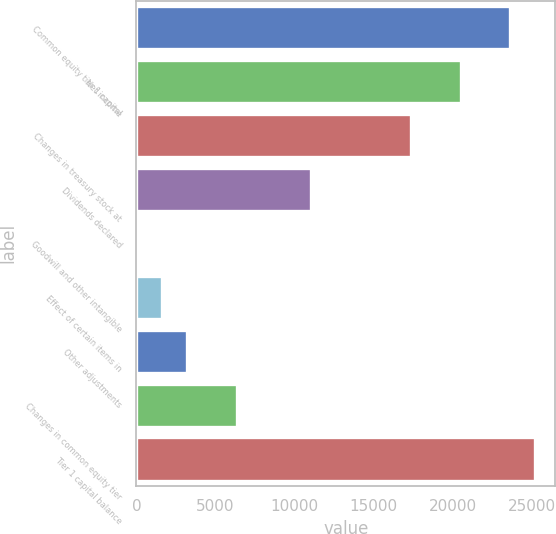Convert chart. <chart><loc_0><loc_0><loc_500><loc_500><bar_chart><fcel>Common equity tier 1 capital<fcel>Net income<fcel>Changes in treasury stock at<fcel>Dividends declared<fcel>Goodwill and other intangible<fcel>Effect of certain items in<fcel>Other adjustments<fcel>Changes in common equity tier<fcel>Tier 1 capital balance<nl><fcel>23643.5<fcel>20500.9<fcel>17358.3<fcel>11073.1<fcel>74<fcel>1645.3<fcel>3216.6<fcel>6359.2<fcel>25214.8<nl></chart> 